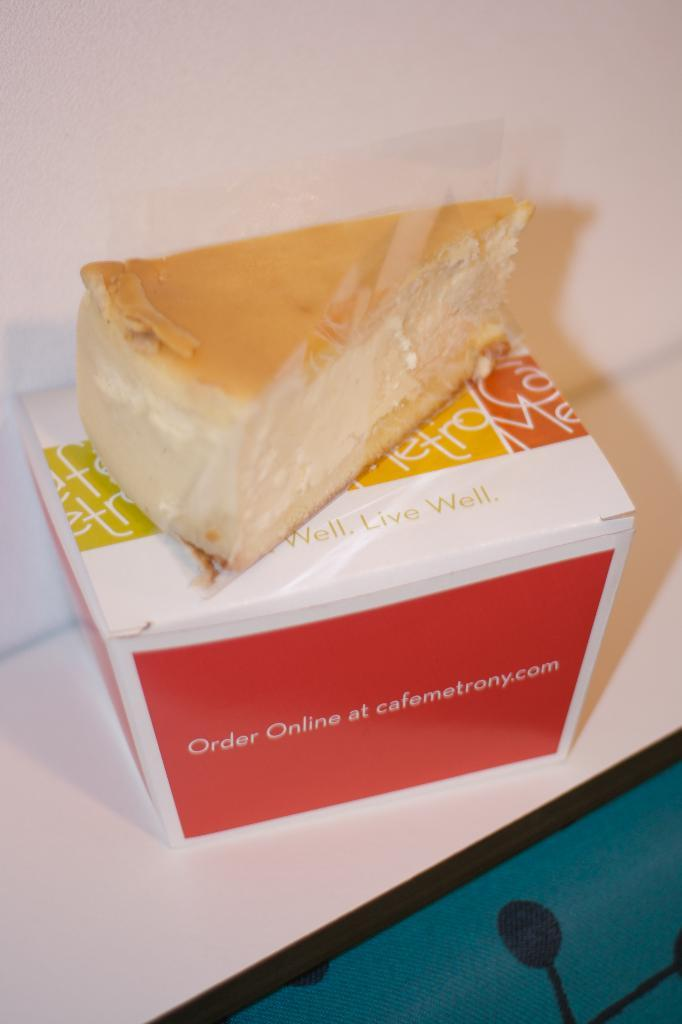What type of container is in the image? There is a paper box in the image. What is inside the container? There is food visible on the box. Are there any markings or text on the container? Yes, there is writing on the box. What type of brass instrument is being played by the grandfather in the image? There is no brass instrument or grandfather present in the image; it only features a paper box with food and writing. 